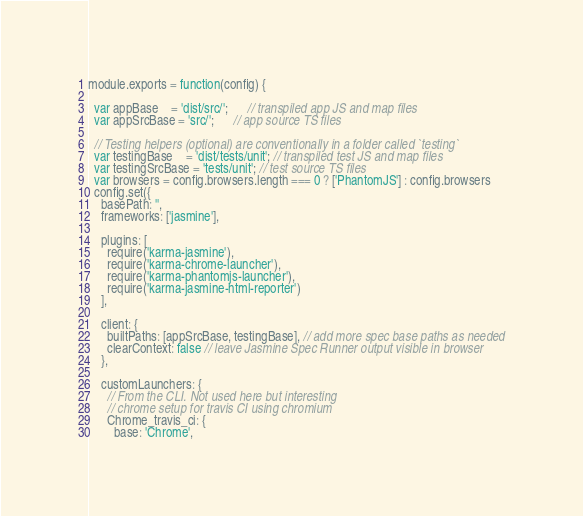Convert code to text. <code><loc_0><loc_0><loc_500><loc_500><_JavaScript_>module.exports = function(config) {

  var appBase    = 'dist/src/';      // transpiled app JS and map files
  var appSrcBase = 'src/';      // app source TS files

  // Testing helpers (optional) are conventionally in a folder called `testing`
  var testingBase    = 'dist/tests/unit'; // transpiled test JS and map files
  var testingSrcBase = 'tests/unit'; // test source TS files
  var browsers = config.browsers.length === 0 ? ['PhantomJS'] : config.browsers
  config.set({
    basePath: '',
    frameworks: ['jasmine'],

    plugins: [
      require('karma-jasmine'),
      require('karma-chrome-launcher'),
      require('karma-phantomjs-launcher'),
      require('karma-jasmine-html-reporter')
    ],

    client: {
      builtPaths: [appSrcBase, testingBase], // add more spec base paths as needed
      clearContext: false // leave Jasmine Spec Runner output visible in browser
    },

    customLaunchers: {
      // From the CLI. Not used here but interesting
      // chrome setup for travis CI using chromium
      Chrome_travis_ci: {
        base: 'Chrome',</code> 